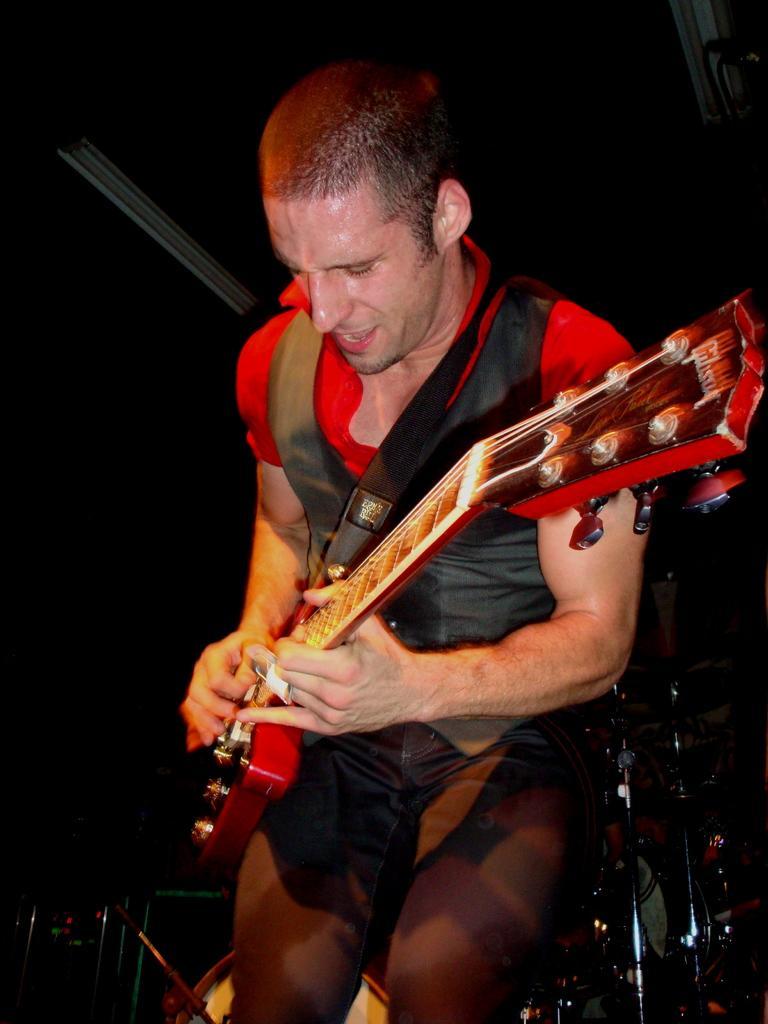How would you summarize this image in a sentence or two? In this image there is a person playing guitar, in the background it is dark. 